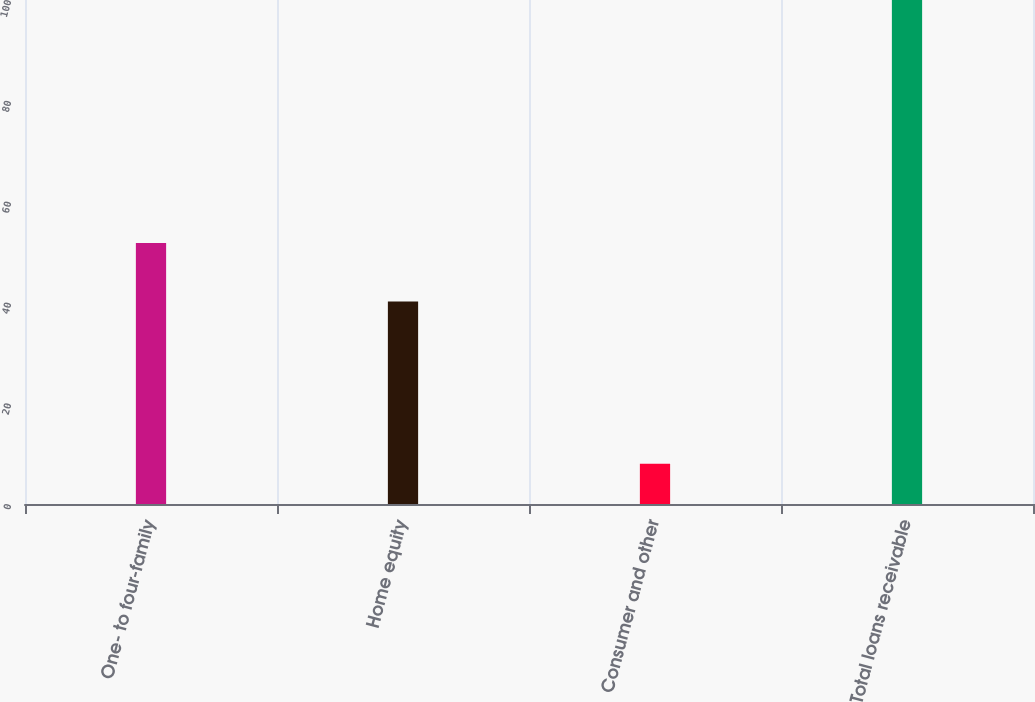<chart> <loc_0><loc_0><loc_500><loc_500><bar_chart><fcel>One- to four-family<fcel>Home equity<fcel>Consumer and other<fcel>Total loans receivable<nl><fcel>51.8<fcel>40.2<fcel>8<fcel>100<nl></chart> 